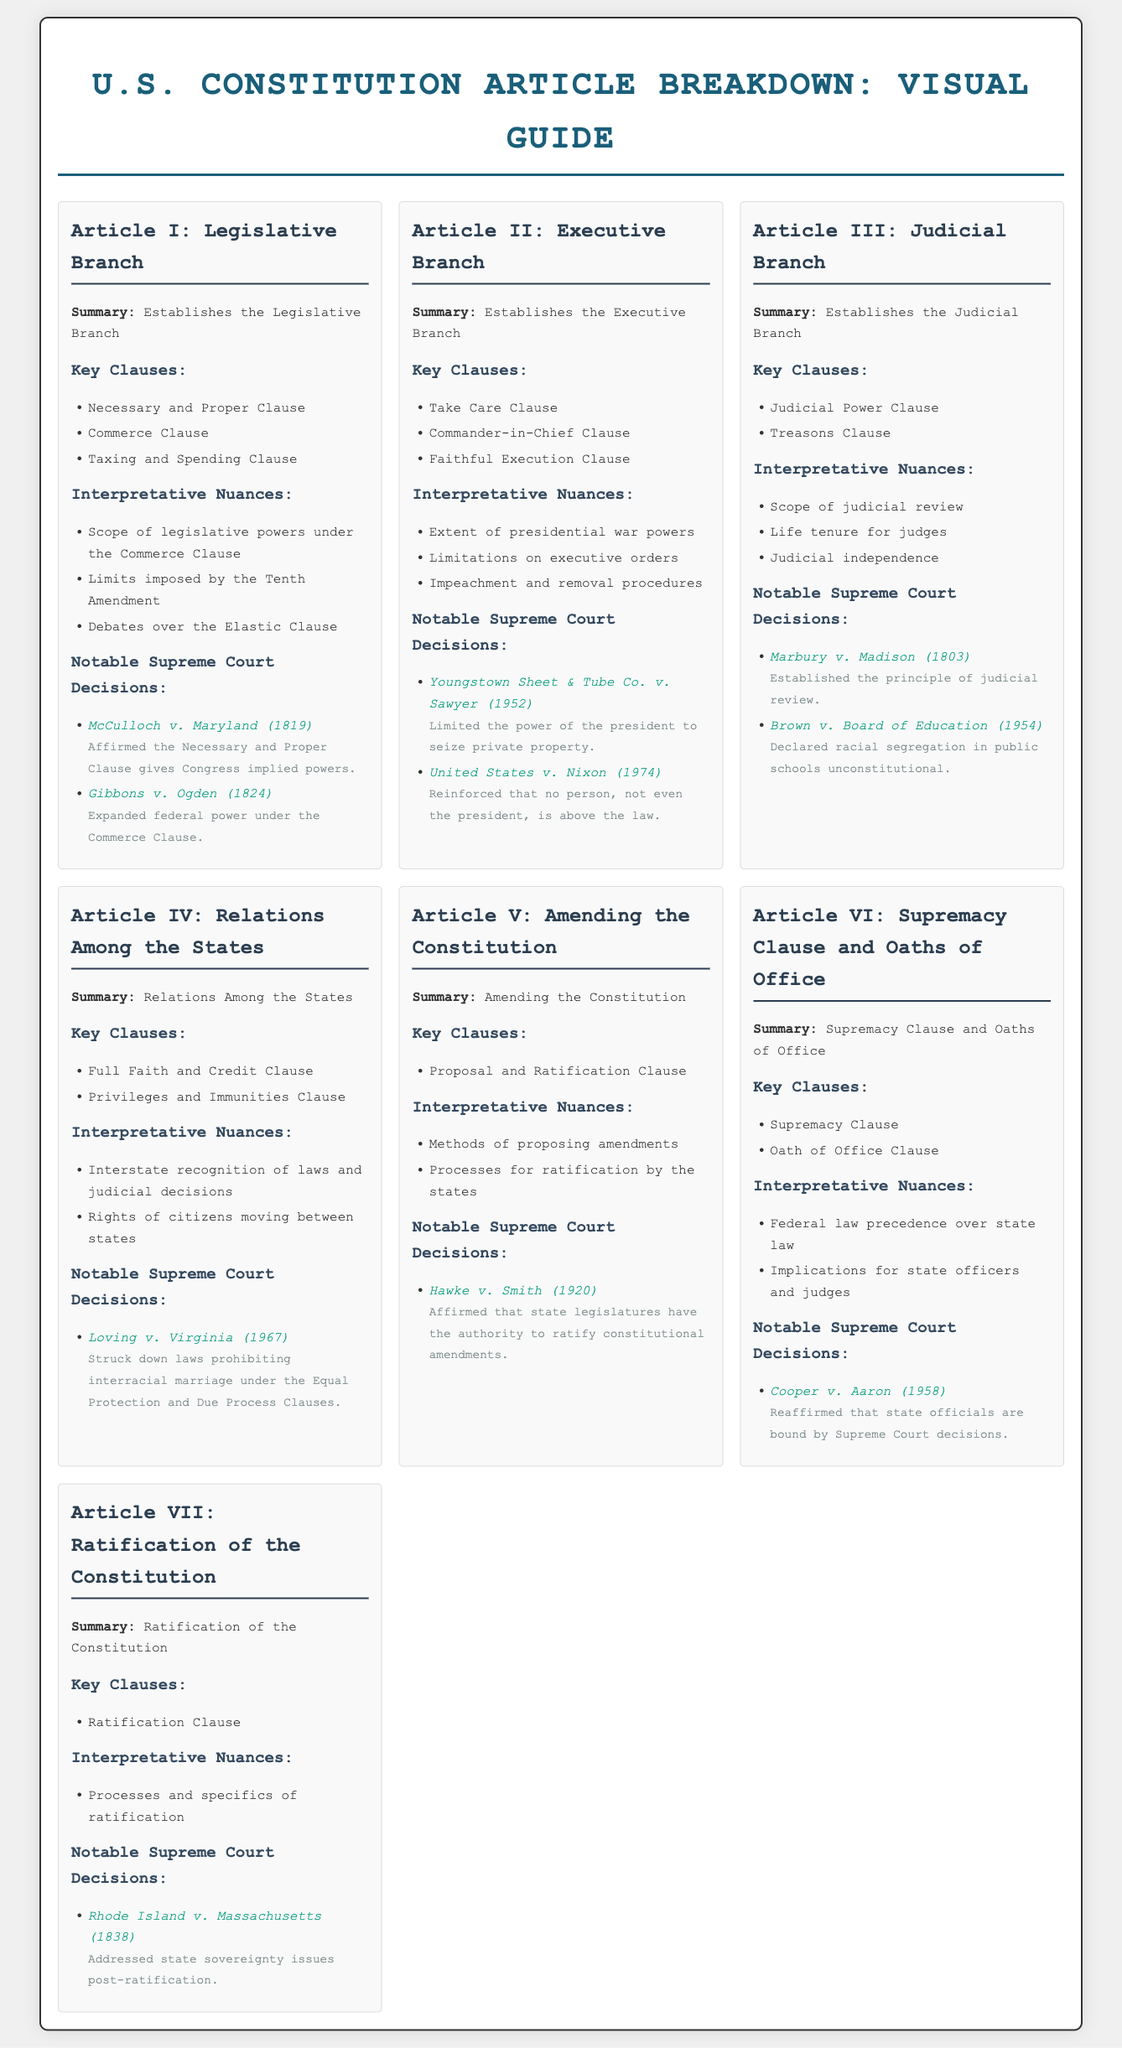what does Article I establish? Article I establishes the Legislative Branch of the U.S. government.
Answer: Legislative Branch what clause expands federal power under the Commerce Clause? The clause that expanded federal power under the Commerce Clause is referenced in Gibbons v. Ogden.
Answer: Commerce Clause which case affirmed the Necessary and Proper Clause gives Congress implied powers? The case that affirmed the Necessary and Proper Clause gives Congress implied powers is McCulloch v. Maryland.
Answer: McCulloch v. Maryland what does Article III establish? Article III establishes the Judicial Branch.
Answer: Judicial Branch what is a notable Supreme Court decision related to the impeachment process? The document does not list a notable Supreme Court decision specifically related to the impeachment process under Article II.
Answer: None how many key clauses are listed under Article VI? There are two key clauses listed under Article VI.
Answer: 2 what is the significance of the Take Care Clause? The Take Care Clause illustrates the president's obligation to enforce the laws faithfully.
Answer: Enforce laws faithfully which article addresses the amendment process of the Constitution? The article that addresses the amendment process of the Constitution is Article V.
Answer: Article V what important principle was established by Marbury v. Madison? Marbury v. Madison established the principle of judicial review.
Answer: Judicial review 